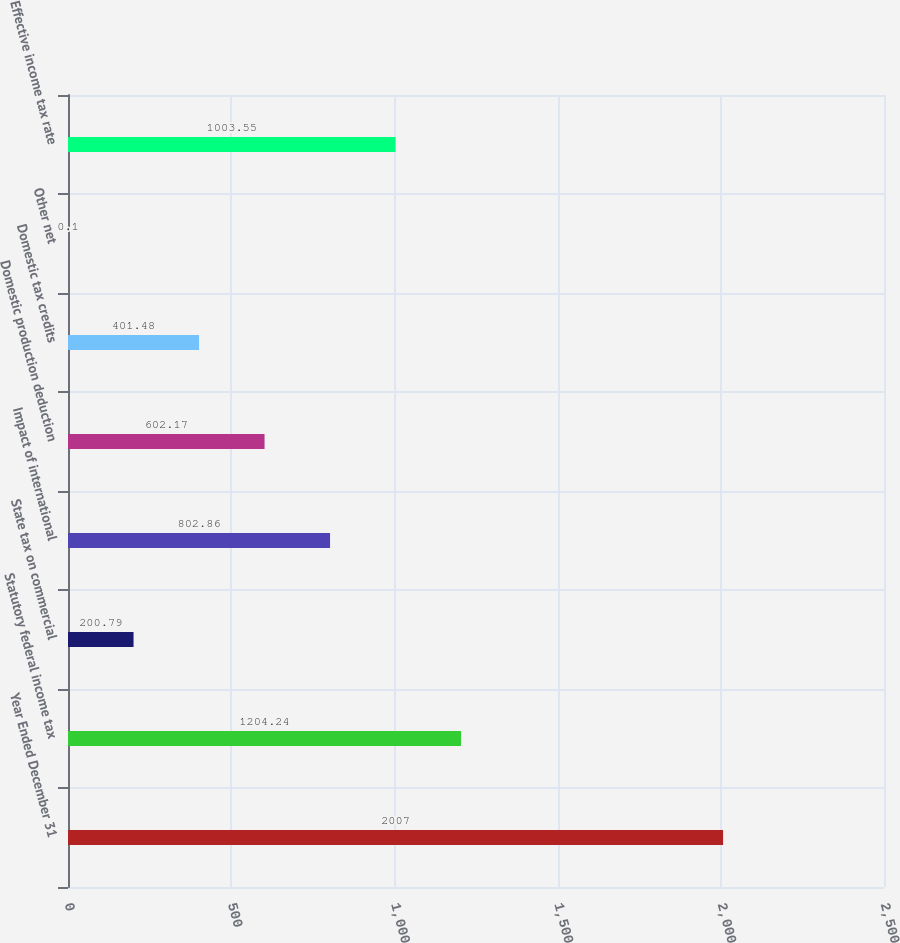<chart> <loc_0><loc_0><loc_500><loc_500><bar_chart><fcel>Year Ended December 31<fcel>Statutory federal income tax<fcel>State tax on commercial<fcel>Impact of international<fcel>Domestic production deduction<fcel>Domestic tax credits<fcel>Other net<fcel>Effective income tax rate<nl><fcel>2007<fcel>1204.24<fcel>200.79<fcel>802.86<fcel>602.17<fcel>401.48<fcel>0.1<fcel>1003.55<nl></chart> 